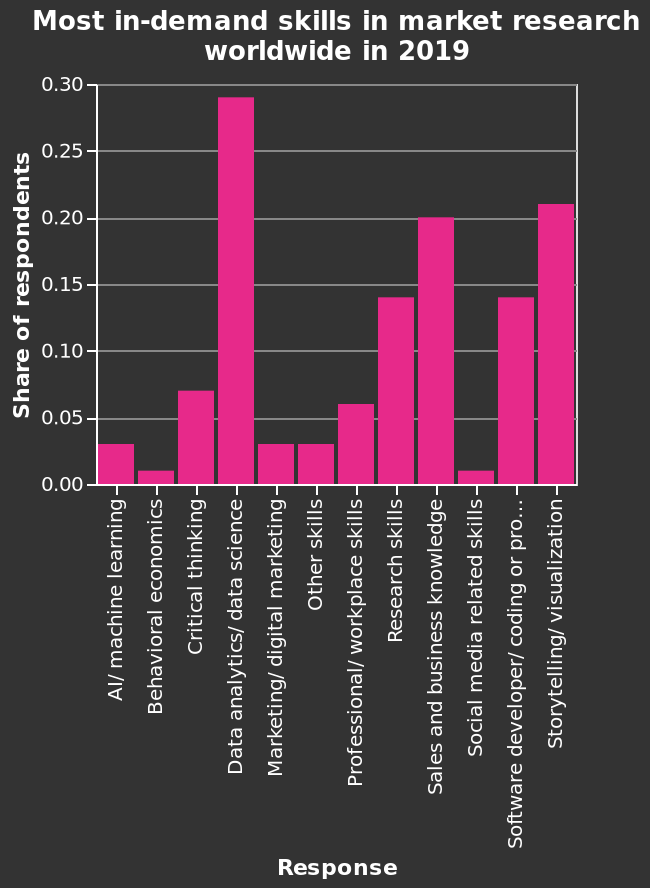<image>
What does the bar diagram represent in terms of market research?  The bar diagram represents the most in-demand skills in market research worldwide in 2019. What is the second most sought-after skill in market research?  The second most sought-after skill in market research is storytelling/visualization. 